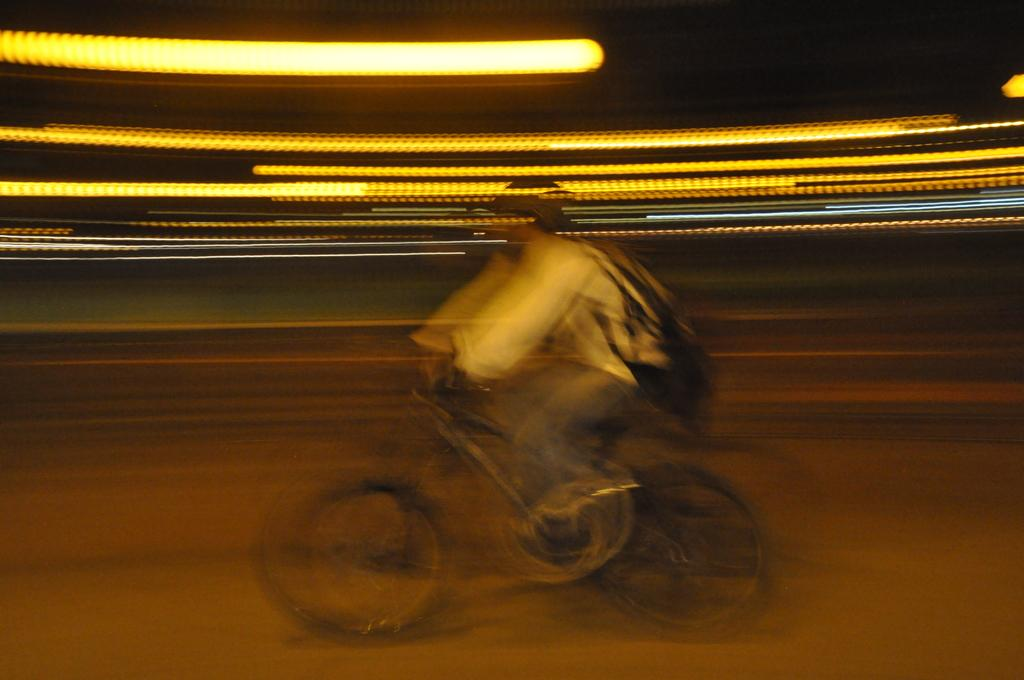Who is the main subject in the image? There is a boy in the image. Where is the boy located in the image? The boy is in the center of the image. What is the boy doing in the image? The boy is riding a bicycle. How many oranges are hanging from the roof in the image? There are no oranges or roof present in the image; it features a boy riding a bicycle. 